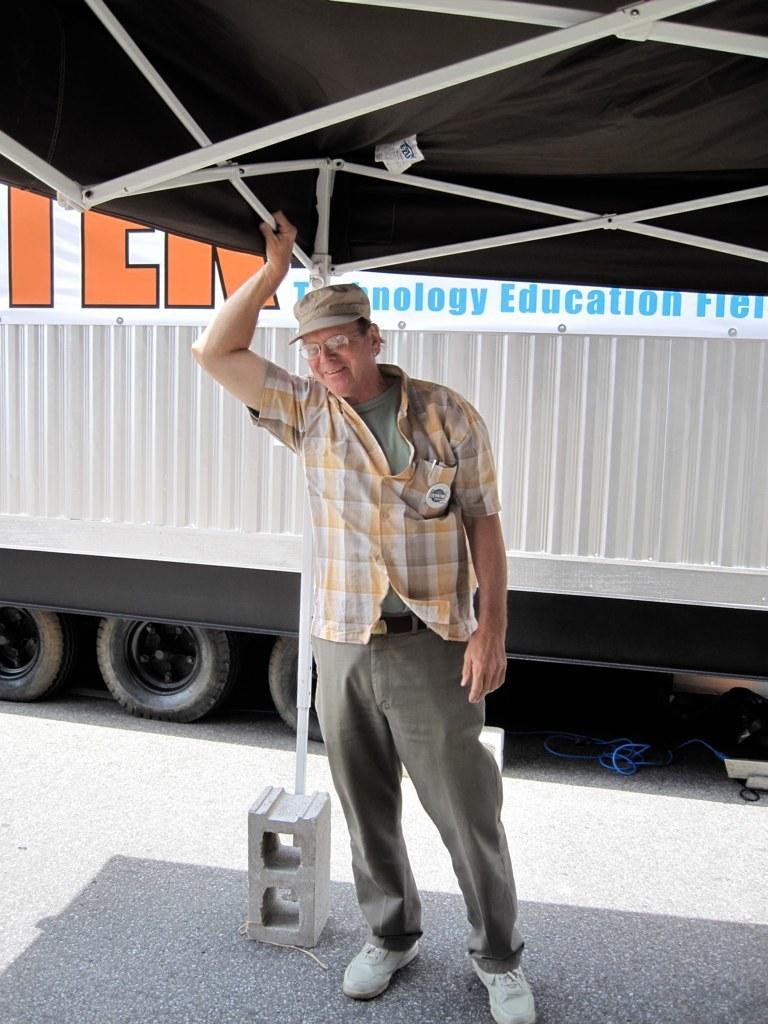What is the person in the image doing? The person is standing in the image and holding a rod. What can be seen on the person's clothing? The person is wearing a green and yellow color shirt. What is visible in the background of the image? There is a vehicle in the background of the image. What color is the vehicle in the image? The vehicle is white in color. How many nuts are being used to propel the person in the image? There are no nuts present in the image, and the person is not being propelled by any means. 